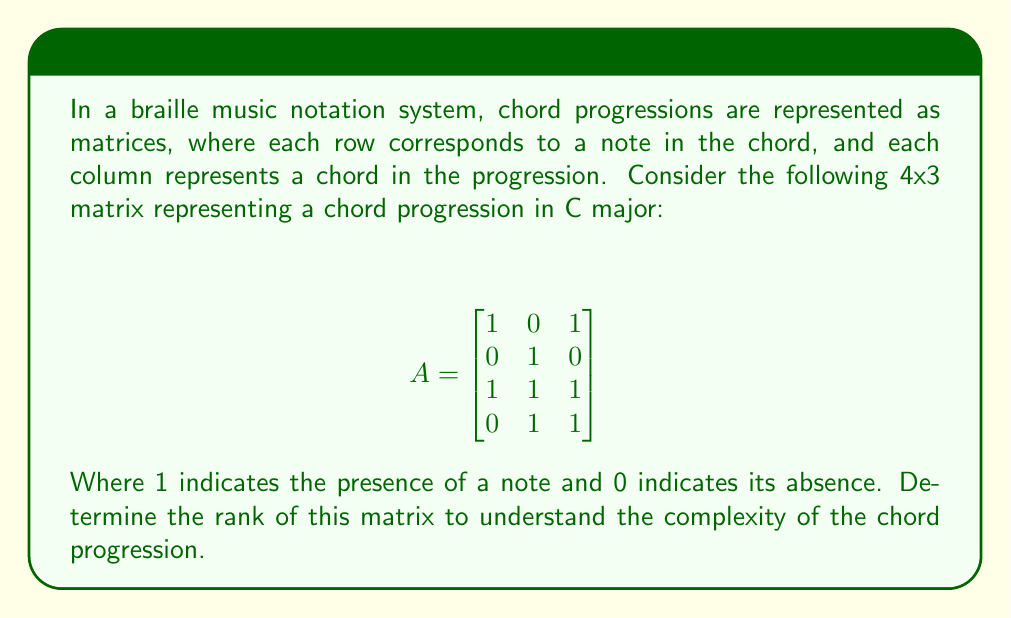Help me with this question. To find the rank of matrix A, we need to determine the number of linearly independent rows or columns. We can do this by performing Gaussian elimination to obtain the row echelon form of the matrix.

Step 1: The matrix is already in partial row echelon form. Let's continue the process:

$$
\begin{bmatrix}
1 & 0 & 1 \\
0 & 1 & 0 \\
1 & 1 & 1 \\
0 & 1 & 1
\end{bmatrix}
$$

Step 2: Subtract row 1 from row 3:

$$
\begin{bmatrix}
1 & 0 & 1 \\
0 & 1 & 0 \\
0 & 1 & 0 \\
0 & 1 & 1
\end{bmatrix}
$$

Step 3: Subtract row 2 from row 3:

$$
\begin{bmatrix}
1 & 0 & 1 \\
0 & 1 & 0 \\
0 & 0 & 0 \\
0 & 1 & 1
\end{bmatrix}
$$

Step 4: Subtract row 2 from row 4:

$$
\begin{bmatrix}
1 & 0 & 1 \\
0 & 1 & 0 \\
0 & 0 & 0 \\
0 & 0 & 1
\end{bmatrix}
$$

The matrix is now in row echelon form. The rank of the matrix is equal to the number of non-zero rows in this form, which is 3.

In the context of chord progressions, this rank indicates that there are 3 linearly independent components in the progression, suggesting a moderate level of complexity in the harmonic structure.
Answer: The rank of the matrix A is 3. 